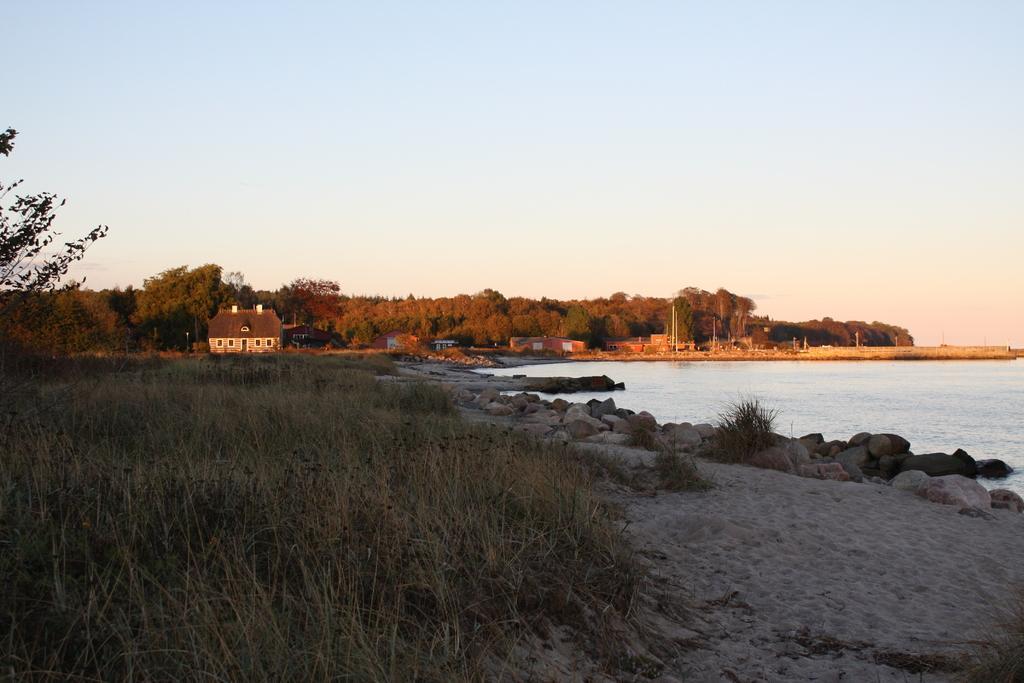Please provide a concise description of this image. In this image there is a grassland, in the background there are trees, houses on the right side there is a lake and a sky. 